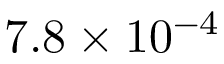Convert formula to latex. <formula><loc_0><loc_0><loc_500><loc_500>7 . 8 \times 1 0 ^ { - 4 }</formula> 